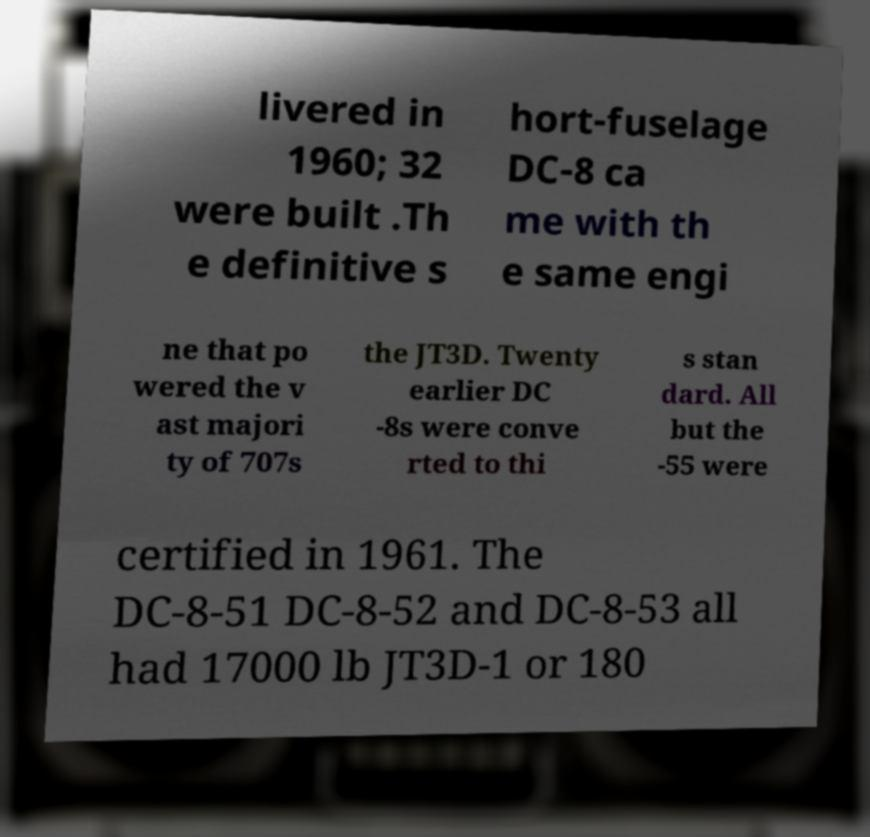Please identify and transcribe the text found in this image. livered in 1960; 32 were built .Th e definitive s hort-fuselage DC-8 ca me with th e same engi ne that po wered the v ast majori ty of 707s the JT3D. Twenty earlier DC -8s were conve rted to thi s stan dard. All but the -55 were certified in 1961. The DC-8-51 DC-8-52 and DC-8-53 all had 17000 lb JT3D-1 or 180 